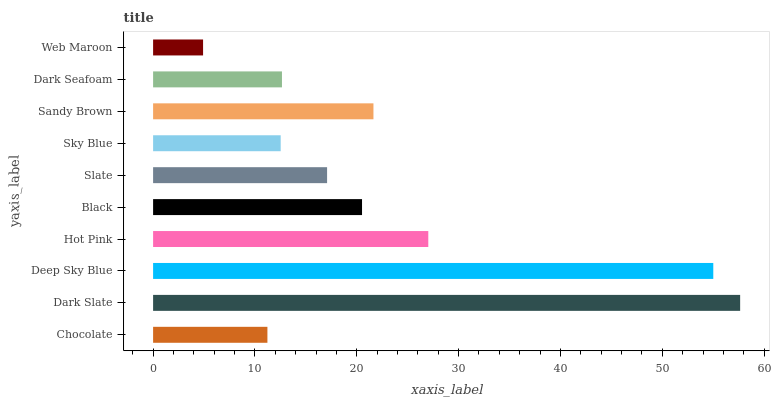Is Web Maroon the minimum?
Answer yes or no. Yes. Is Dark Slate the maximum?
Answer yes or no. Yes. Is Deep Sky Blue the minimum?
Answer yes or no. No. Is Deep Sky Blue the maximum?
Answer yes or no. No. Is Dark Slate greater than Deep Sky Blue?
Answer yes or no. Yes. Is Deep Sky Blue less than Dark Slate?
Answer yes or no. Yes. Is Deep Sky Blue greater than Dark Slate?
Answer yes or no. No. Is Dark Slate less than Deep Sky Blue?
Answer yes or no. No. Is Black the high median?
Answer yes or no. Yes. Is Slate the low median?
Answer yes or no. Yes. Is Web Maroon the high median?
Answer yes or no. No. Is Hot Pink the low median?
Answer yes or no. No. 